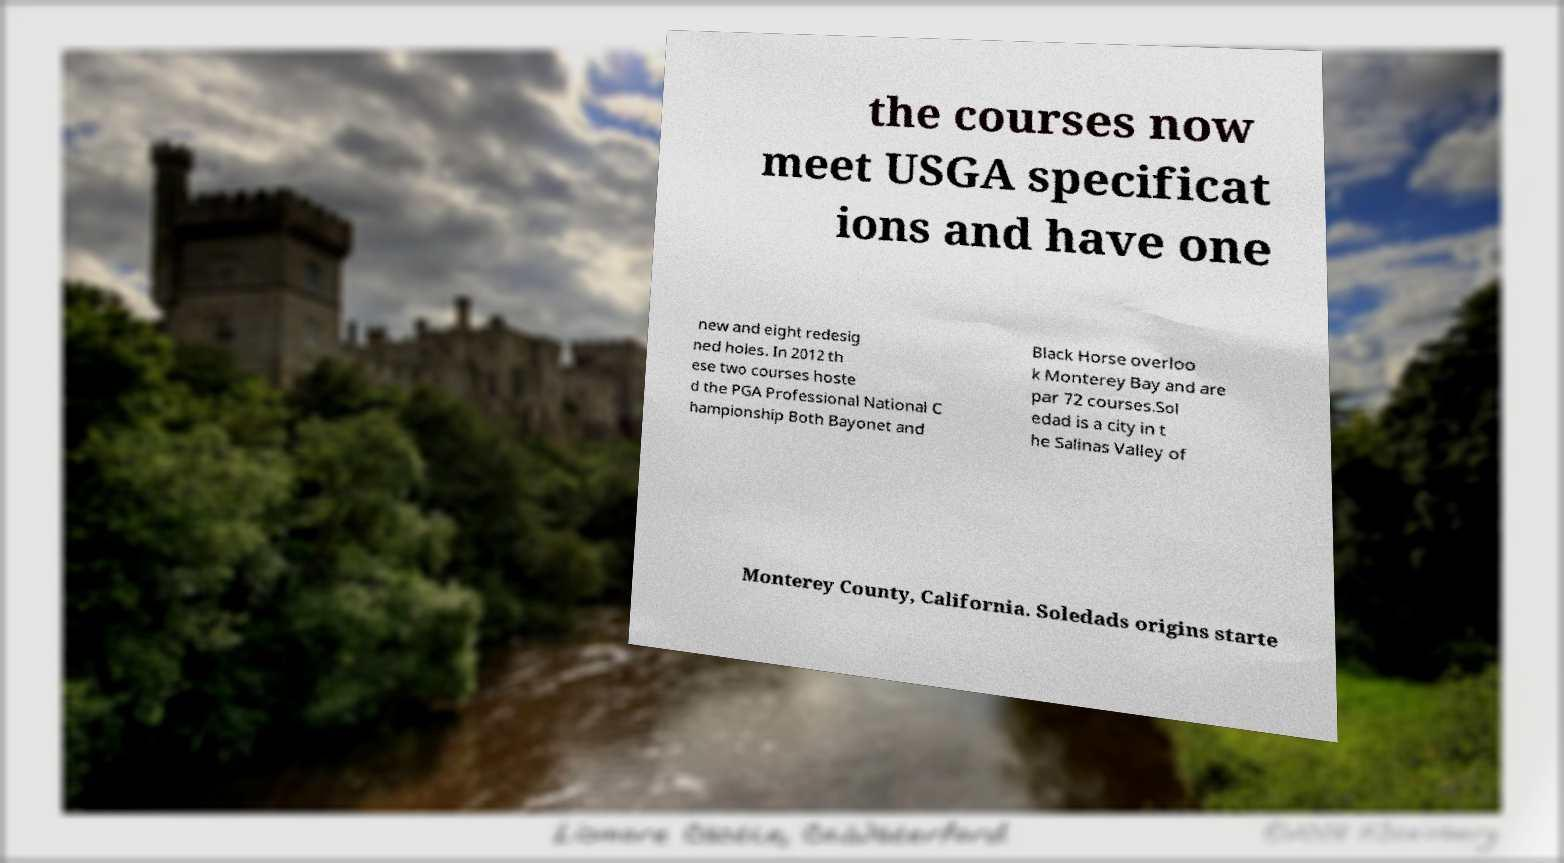I need the written content from this picture converted into text. Can you do that? the courses now meet USGA specificat ions and have one new and eight redesig ned holes. In 2012 th ese two courses hoste d the PGA Professional National C hampionship Both Bayonet and Black Horse overloo k Monterey Bay and are par 72 courses.Sol edad is a city in t he Salinas Valley of Monterey County, California. Soledads origins starte 